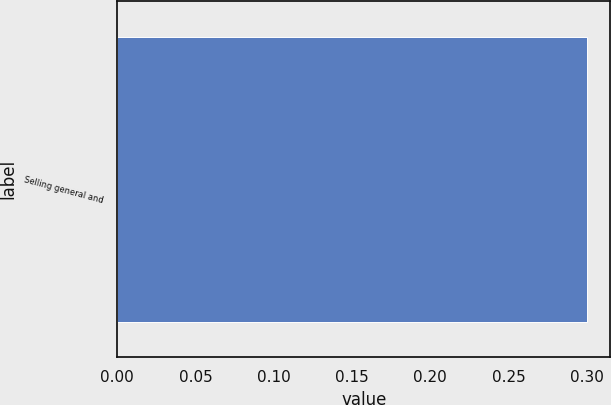<chart> <loc_0><loc_0><loc_500><loc_500><bar_chart><fcel>Selling general and<nl><fcel>0.3<nl></chart> 